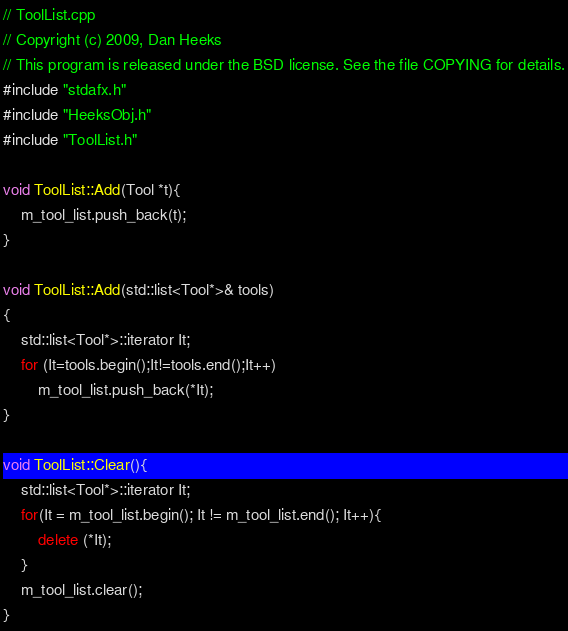Convert code to text. <code><loc_0><loc_0><loc_500><loc_500><_C++_>// ToolList.cpp
// Copyright (c) 2009, Dan Heeks
// This program is released under the BSD license. See the file COPYING for details.
#include "stdafx.h"
#include "HeeksObj.h"
#include "ToolList.h"

void ToolList::Add(Tool *t){
	m_tool_list.push_back(t);
}

void ToolList::Add(std::list<Tool*>& tools)
{
	std::list<Tool*>::iterator It;
	for (It=tools.begin();It!=tools.end();It++)
		m_tool_list.push_back(*It);
}

void ToolList::Clear(){
	std::list<Tool*>::iterator It;
	for(It = m_tool_list.begin(); It != m_tool_list.end(); It++){
		delete (*It);
	}
	m_tool_list.clear();
}
</code> 